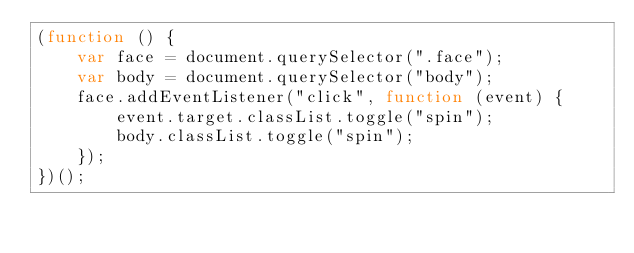<code> <loc_0><loc_0><loc_500><loc_500><_JavaScript_>(function () {
    var face = document.querySelector(".face");
    var body = document.querySelector("body");
    face.addEventListener("click", function (event) {
        event.target.classList.toggle("spin");
        body.classList.toggle("spin");
    });
})();
</code> 